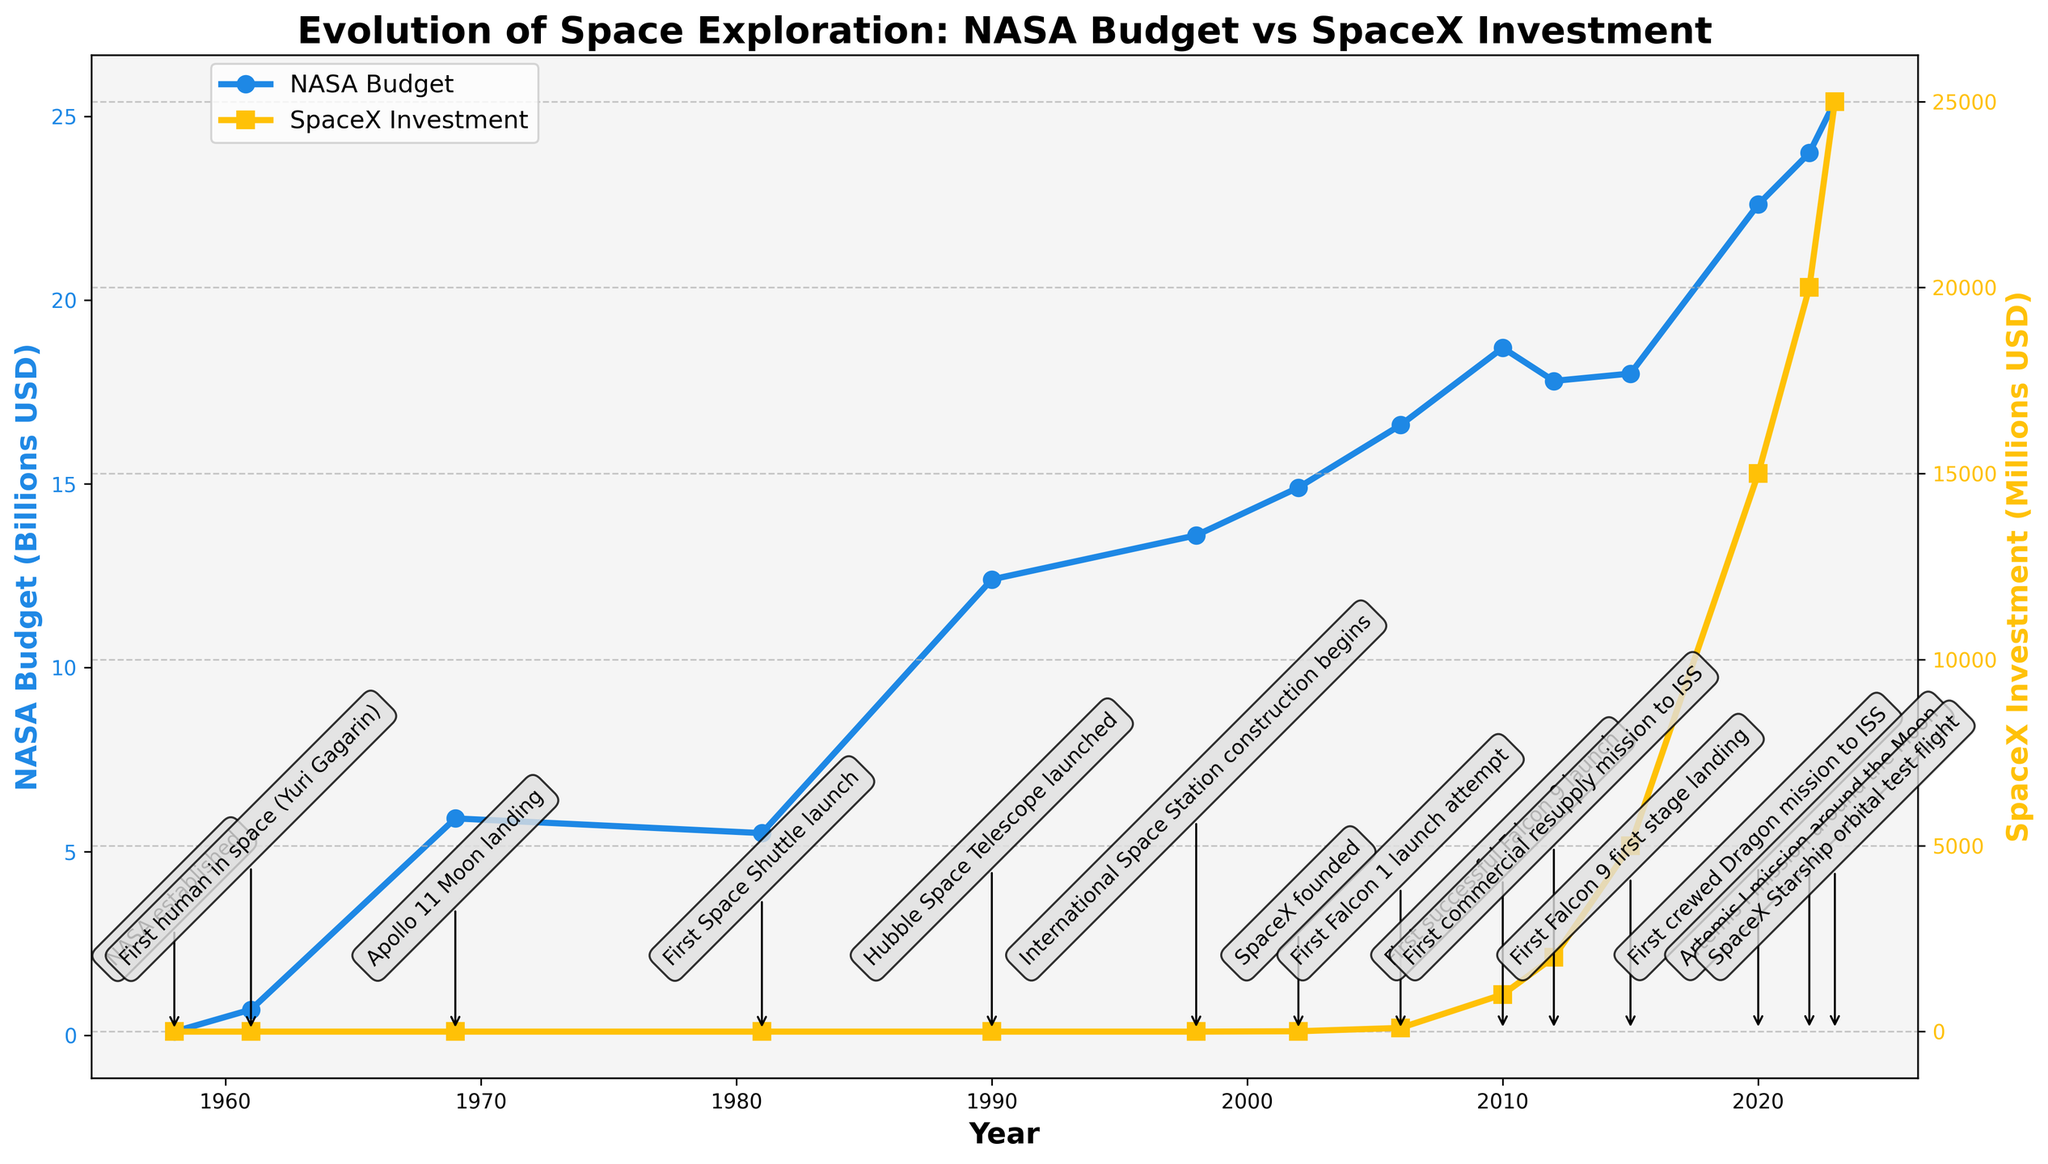Which year did NASA have the highest budget? By looking at the plot, the year with the highest point in the NASA Budget line is observed.
Answer: 2023 Which milestone coincided with the establishment of NASA? The milestone annotations show that "NASA established" occurred in 1958.
Answer: 1958 How did SpaceX's investment change between 2012 and 2015? Refer to the SpaceX Investment line and compare values in 2012 and 2015: the investment increased from 2000 million USD to 5000 million USD.
Answer: Increased by 3000 million USD Compare the NASA budget and SpaceX investment in 2020. Which was higher? In 2020, the figure shows NASA Budget at 22.6 billion USD and SpaceX Investment at 15000 million USD, converting SpaceX's investment to billion USD gives 15 billion USD. Thus, NASA's budget was higher.
Answer: NASA budget What significant milestone happened in 1969, and what was NASA's budget that year? The annotation for 1969 shows "Apollo 11 Moon landing," and the corresponding point on NASA Budget line indicates a budget of 5.9 billion USD.
Answer: Apollo 11 Moon landing, 5.9 billion USD Calculate the difference in NASA's budget between 1998 and 2023. Subtract NASA Budget in 1998 (13.6 billion USD) from NASA Budget in 2023 (25.4 billion USD). The difference is 25.4 - 13.6 = 11.8 billion USD.
Answer: 11.8 billion USD What trend can you observe in SpaceX's investment from 2006 to 2023? The plot shows a consistent upward trend in SpaceX Investment from 100 million USD in 2006 to 25000 million USD in 2023.
Answer: Consistent upward trend Compare the spacing of milestones for NASA and SpaceX. Which organization had milestones occur more frequently? Visual examination of the plot reveals that NASA milestones are more spread out over time, while SpaceX milestones are clustered closer together from 2002 onward.
Answer: SpaceX In which years did NASA's budget experience a decrease compared to the previous year? Identify the years where the NASA Budget line shows a downward trend: 2010 (18.7 to 17.8) and 2012 (17.8 to 18.0 marking recovery afterward).
Answer: 2010, 2012 